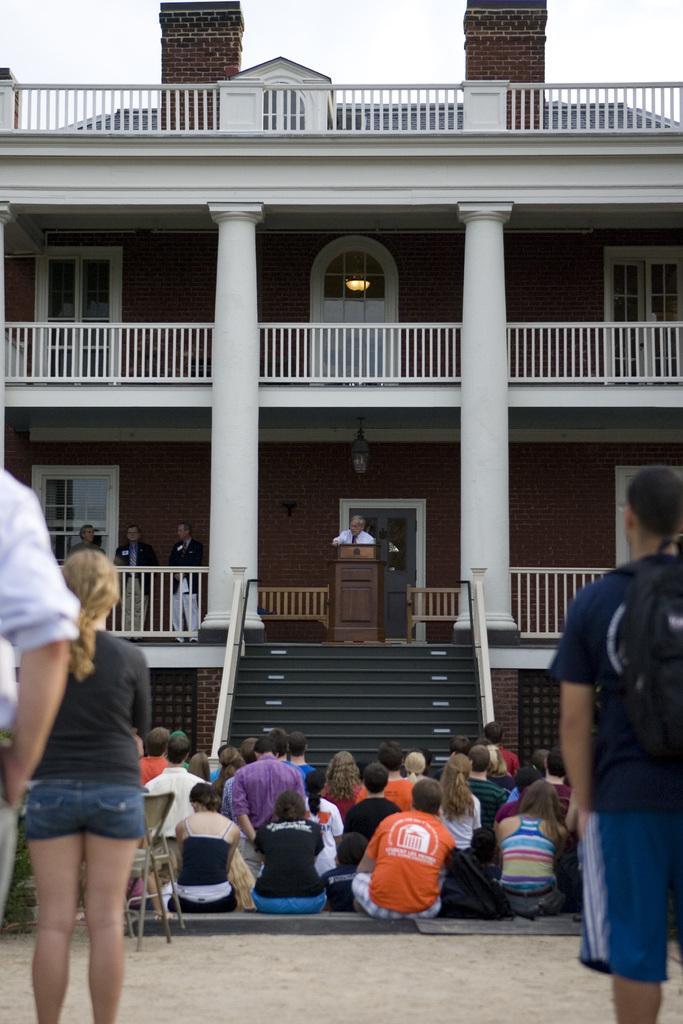Can you describe this image briefly? In front of the picture, we see three people are standing. At the bottom, we see the pavement. In the middle, we see the people are sitting on the floor. Beside them, we see a chair. In front of them, we see the staircase, stair railing and a man is standing. In front of him, we see a podium and he might be talking on the microphone. On the left side, we see three men are standing. In the background, we see the railings, pillars, lights and a building in white and brown color. At the top, we see the sky. 